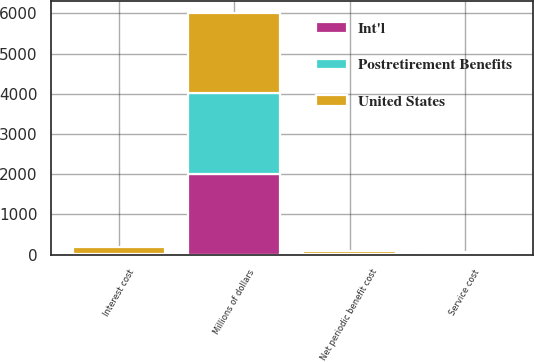Convert chart. <chart><loc_0><loc_0><loc_500><loc_500><stacked_bar_chart><ecel><fcel>Millions of dollars<fcel>Service cost<fcel>Interest cost<fcel>Net periodic benefit cost<nl><fcel>Postretirement Benefits<fcel>2005<fcel>1<fcel>9<fcel>4<nl><fcel>United States<fcel>2005<fcel>72<fcel>172<fcel>80<nl><fcel>Int'l<fcel>2005<fcel>1<fcel>10<fcel>10<nl></chart> 